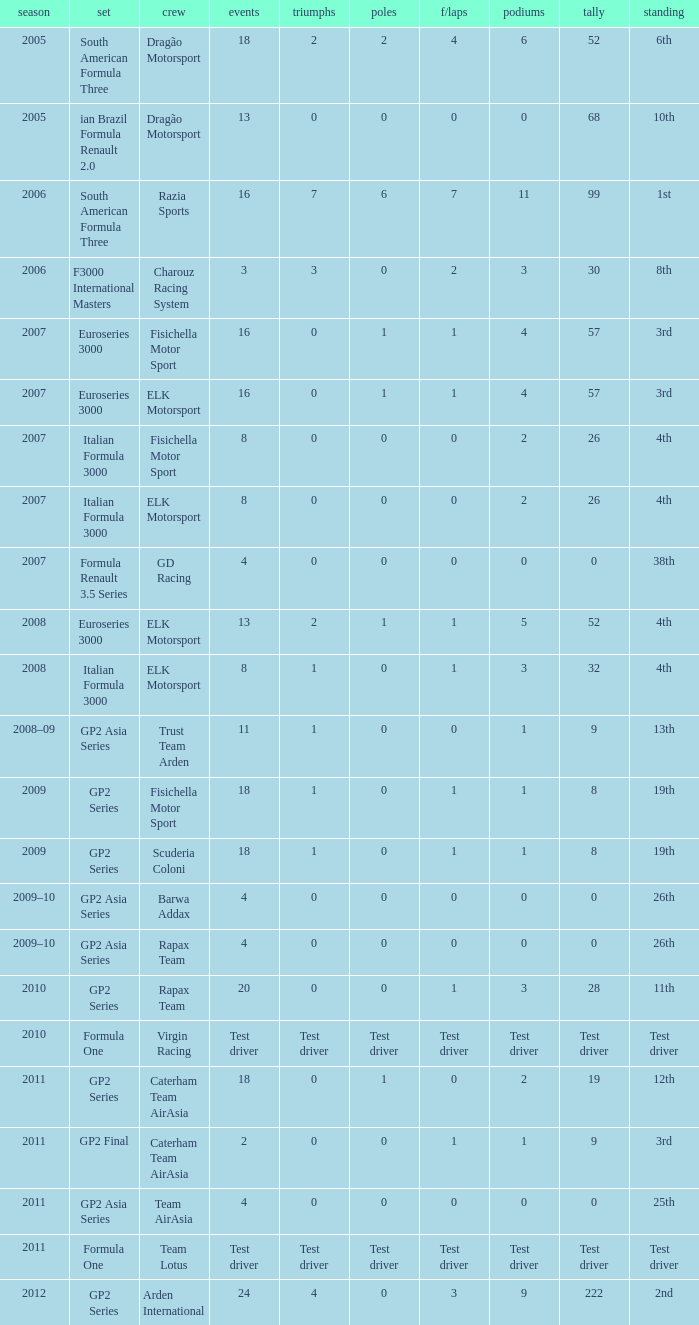What were the points in the year when his Wins were 0, his Podiums were 0, and he drove in 4 races? 0, 0, 0, 0. 